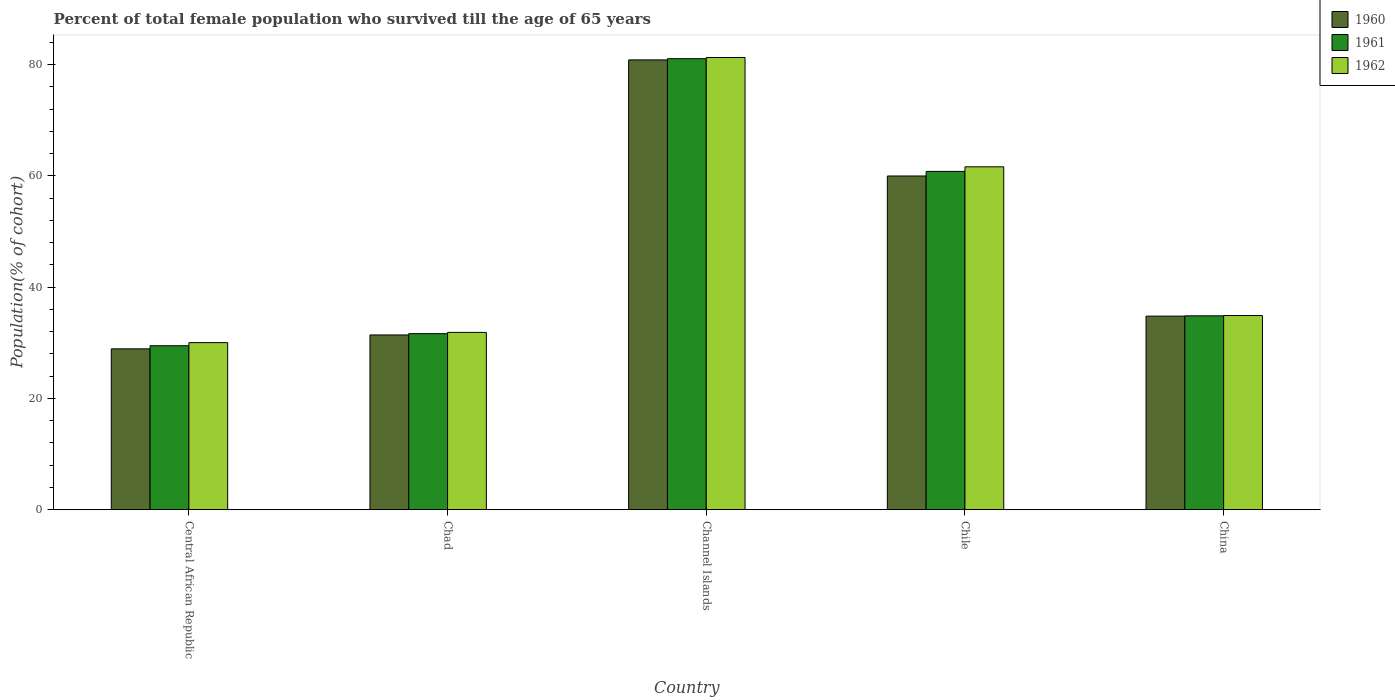Are the number of bars on each tick of the X-axis equal?
Your answer should be compact. Yes. How many bars are there on the 5th tick from the left?
Keep it short and to the point. 3. How many bars are there on the 2nd tick from the right?
Ensure brevity in your answer.  3. What is the label of the 2nd group of bars from the left?
Your answer should be compact. Chad. What is the percentage of total female population who survived till the age of 65 years in 1960 in Central African Republic?
Your response must be concise. 28.91. Across all countries, what is the maximum percentage of total female population who survived till the age of 65 years in 1960?
Offer a terse response. 80.85. Across all countries, what is the minimum percentage of total female population who survived till the age of 65 years in 1962?
Your answer should be compact. 30.03. In which country was the percentage of total female population who survived till the age of 65 years in 1962 maximum?
Offer a very short reply. Channel Islands. In which country was the percentage of total female population who survived till the age of 65 years in 1960 minimum?
Offer a very short reply. Central African Republic. What is the total percentage of total female population who survived till the age of 65 years in 1961 in the graph?
Provide a succinct answer. 237.84. What is the difference between the percentage of total female population who survived till the age of 65 years in 1961 in Chad and that in Channel Islands?
Give a very brief answer. -49.43. What is the difference between the percentage of total female population who survived till the age of 65 years in 1961 in China and the percentage of total female population who survived till the age of 65 years in 1960 in Chile?
Offer a very short reply. -25.13. What is the average percentage of total female population who survived till the age of 65 years in 1962 per country?
Offer a very short reply. 47.94. What is the difference between the percentage of total female population who survived till the age of 65 years of/in 1960 and percentage of total female population who survived till the age of 65 years of/in 1961 in Central African Republic?
Provide a short and direct response. -0.56. What is the ratio of the percentage of total female population who survived till the age of 65 years in 1961 in Chad to that in Chile?
Offer a very short reply. 0.52. Is the difference between the percentage of total female population who survived till the age of 65 years in 1960 in Channel Islands and Chile greater than the difference between the percentage of total female population who survived till the age of 65 years in 1961 in Channel Islands and Chile?
Offer a terse response. Yes. What is the difference between the highest and the second highest percentage of total female population who survived till the age of 65 years in 1960?
Offer a very short reply. 46.06. What is the difference between the highest and the lowest percentage of total female population who survived till the age of 65 years in 1962?
Offer a terse response. 51.26. In how many countries, is the percentage of total female population who survived till the age of 65 years in 1960 greater than the average percentage of total female population who survived till the age of 65 years in 1960 taken over all countries?
Provide a succinct answer. 2. Is the sum of the percentage of total female population who survived till the age of 65 years in 1960 in Chile and China greater than the maximum percentage of total female population who survived till the age of 65 years in 1962 across all countries?
Ensure brevity in your answer.  Yes. Is it the case that in every country, the sum of the percentage of total female population who survived till the age of 65 years in 1961 and percentage of total female population who survived till the age of 65 years in 1962 is greater than the percentage of total female population who survived till the age of 65 years in 1960?
Provide a succinct answer. Yes. Are all the bars in the graph horizontal?
Ensure brevity in your answer.  No. How many countries are there in the graph?
Your answer should be very brief. 5. Are the values on the major ticks of Y-axis written in scientific E-notation?
Your response must be concise. No. Does the graph contain any zero values?
Provide a succinct answer. No. What is the title of the graph?
Your answer should be compact. Percent of total female population who survived till the age of 65 years. Does "1969" appear as one of the legend labels in the graph?
Your answer should be very brief. No. What is the label or title of the Y-axis?
Provide a short and direct response. Population(% of cohort). What is the Population(% of cohort) of 1960 in Central African Republic?
Your answer should be very brief. 28.91. What is the Population(% of cohort) in 1961 in Central African Republic?
Ensure brevity in your answer.  29.47. What is the Population(% of cohort) of 1962 in Central African Republic?
Give a very brief answer. 30.03. What is the Population(% of cohort) of 1960 in Chad?
Ensure brevity in your answer.  31.41. What is the Population(% of cohort) of 1961 in Chad?
Your answer should be compact. 31.64. What is the Population(% of cohort) of 1962 in Chad?
Provide a short and direct response. 31.87. What is the Population(% of cohort) in 1960 in Channel Islands?
Your answer should be very brief. 80.85. What is the Population(% of cohort) of 1961 in Channel Islands?
Offer a very short reply. 81.07. What is the Population(% of cohort) of 1962 in Channel Islands?
Provide a short and direct response. 81.28. What is the Population(% of cohort) of 1960 in Chile?
Ensure brevity in your answer.  59.98. What is the Population(% of cohort) in 1961 in Chile?
Provide a succinct answer. 60.81. What is the Population(% of cohort) of 1962 in Chile?
Your answer should be very brief. 61.63. What is the Population(% of cohort) of 1960 in China?
Offer a very short reply. 34.79. What is the Population(% of cohort) of 1961 in China?
Your answer should be compact. 34.85. What is the Population(% of cohort) in 1962 in China?
Provide a succinct answer. 34.9. Across all countries, what is the maximum Population(% of cohort) in 1960?
Make the answer very short. 80.85. Across all countries, what is the maximum Population(% of cohort) of 1961?
Keep it short and to the point. 81.07. Across all countries, what is the maximum Population(% of cohort) in 1962?
Offer a very short reply. 81.28. Across all countries, what is the minimum Population(% of cohort) of 1960?
Ensure brevity in your answer.  28.91. Across all countries, what is the minimum Population(% of cohort) of 1961?
Provide a short and direct response. 29.47. Across all countries, what is the minimum Population(% of cohort) in 1962?
Offer a very short reply. 30.03. What is the total Population(% of cohort) of 1960 in the graph?
Keep it short and to the point. 235.95. What is the total Population(% of cohort) of 1961 in the graph?
Ensure brevity in your answer.  237.84. What is the total Population(% of cohort) in 1962 in the graph?
Keep it short and to the point. 239.72. What is the difference between the Population(% of cohort) of 1960 in Central African Republic and that in Chad?
Ensure brevity in your answer.  -2.5. What is the difference between the Population(% of cohort) in 1961 in Central African Republic and that in Chad?
Ensure brevity in your answer.  -2.17. What is the difference between the Population(% of cohort) of 1962 in Central African Republic and that in Chad?
Your response must be concise. -1.84. What is the difference between the Population(% of cohort) in 1960 in Central African Republic and that in Channel Islands?
Your answer should be compact. -51.94. What is the difference between the Population(% of cohort) in 1961 in Central African Republic and that in Channel Islands?
Your answer should be very brief. -51.6. What is the difference between the Population(% of cohort) in 1962 in Central African Republic and that in Channel Islands?
Your answer should be very brief. -51.26. What is the difference between the Population(% of cohort) of 1960 in Central African Republic and that in Chile?
Keep it short and to the point. -31.07. What is the difference between the Population(% of cohort) of 1961 in Central African Republic and that in Chile?
Offer a terse response. -31.34. What is the difference between the Population(% of cohort) of 1962 in Central African Republic and that in Chile?
Your answer should be compact. -31.6. What is the difference between the Population(% of cohort) in 1960 in Central African Republic and that in China?
Keep it short and to the point. -5.88. What is the difference between the Population(% of cohort) in 1961 in Central African Republic and that in China?
Provide a succinct answer. -5.38. What is the difference between the Population(% of cohort) in 1962 in Central African Republic and that in China?
Your answer should be compact. -4.88. What is the difference between the Population(% of cohort) in 1960 in Chad and that in Channel Islands?
Keep it short and to the point. -49.44. What is the difference between the Population(% of cohort) in 1961 in Chad and that in Channel Islands?
Your answer should be very brief. -49.43. What is the difference between the Population(% of cohort) of 1962 in Chad and that in Channel Islands?
Provide a succinct answer. -49.41. What is the difference between the Population(% of cohort) of 1960 in Chad and that in Chile?
Your response must be concise. -28.57. What is the difference between the Population(% of cohort) in 1961 in Chad and that in Chile?
Provide a succinct answer. -29.16. What is the difference between the Population(% of cohort) of 1962 in Chad and that in Chile?
Offer a very short reply. -29.76. What is the difference between the Population(% of cohort) of 1960 in Chad and that in China?
Ensure brevity in your answer.  -3.38. What is the difference between the Population(% of cohort) of 1961 in Chad and that in China?
Offer a very short reply. -3.21. What is the difference between the Population(% of cohort) of 1962 in Chad and that in China?
Ensure brevity in your answer.  -3.03. What is the difference between the Population(% of cohort) in 1960 in Channel Islands and that in Chile?
Offer a terse response. 20.87. What is the difference between the Population(% of cohort) in 1961 in Channel Islands and that in Chile?
Your answer should be very brief. 20.26. What is the difference between the Population(% of cohort) of 1962 in Channel Islands and that in Chile?
Ensure brevity in your answer.  19.65. What is the difference between the Population(% of cohort) of 1960 in Channel Islands and that in China?
Your response must be concise. 46.06. What is the difference between the Population(% of cohort) of 1961 in Channel Islands and that in China?
Keep it short and to the point. 46.22. What is the difference between the Population(% of cohort) of 1962 in Channel Islands and that in China?
Ensure brevity in your answer.  46.38. What is the difference between the Population(% of cohort) of 1960 in Chile and that in China?
Offer a terse response. 25.19. What is the difference between the Population(% of cohort) of 1961 in Chile and that in China?
Your answer should be very brief. 25.96. What is the difference between the Population(% of cohort) in 1962 in Chile and that in China?
Offer a very short reply. 26.73. What is the difference between the Population(% of cohort) of 1960 in Central African Republic and the Population(% of cohort) of 1961 in Chad?
Provide a short and direct response. -2.73. What is the difference between the Population(% of cohort) in 1960 in Central African Republic and the Population(% of cohort) in 1962 in Chad?
Your answer should be compact. -2.96. What is the difference between the Population(% of cohort) of 1961 in Central African Republic and the Population(% of cohort) of 1962 in Chad?
Ensure brevity in your answer.  -2.4. What is the difference between the Population(% of cohort) of 1960 in Central African Republic and the Population(% of cohort) of 1961 in Channel Islands?
Your response must be concise. -52.16. What is the difference between the Population(% of cohort) of 1960 in Central African Republic and the Population(% of cohort) of 1962 in Channel Islands?
Your answer should be very brief. -52.37. What is the difference between the Population(% of cohort) of 1961 in Central African Republic and the Population(% of cohort) of 1962 in Channel Islands?
Offer a terse response. -51.81. What is the difference between the Population(% of cohort) of 1960 in Central African Republic and the Population(% of cohort) of 1961 in Chile?
Your answer should be compact. -31.89. What is the difference between the Population(% of cohort) of 1960 in Central African Republic and the Population(% of cohort) of 1962 in Chile?
Keep it short and to the point. -32.72. What is the difference between the Population(% of cohort) in 1961 in Central African Republic and the Population(% of cohort) in 1962 in Chile?
Offer a very short reply. -32.16. What is the difference between the Population(% of cohort) in 1960 in Central African Republic and the Population(% of cohort) in 1961 in China?
Offer a very short reply. -5.94. What is the difference between the Population(% of cohort) in 1960 in Central African Republic and the Population(% of cohort) in 1962 in China?
Offer a terse response. -5.99. What is the difference between the Population(% of cohort) in 1961 in Central African Republic and the Population(% of cohort) in 1962 in China?
Ensure brevity in your answer.  -5.43. What is the difference between the Population(% of cohort) in 1960 in Chad and the Population(% of cohort) in 1961 in Channel Islands?
Offer a very short reply. -49.66. What is the difference between the Population(% of cohort) of 1960 in Chad and the Population(% of cohort) of 1962 in Channel Islands?
Provide a short and direct response. -49.87. What is the difference between the Population(% of cohort) in 1961 in Chad and the Population(% of cohort) in 1962 in Channel Islands?
Your answer should be very brief. -49.64. What is the difference between the Population(% of cohort) in 1960 in Chad and the Population(% of cohort) in 1961 in Chile?
Your answer should be compact. -29.39. What is the difference between the Population(% of cohort) of 1960 in Chad and the Population(% of cohort) of 1962 in Chile?
Provide a short and direct response. -30.22. What is the difference between the Population(% of cohort) of 1961 in Chad and the Population(% of cohort) of 1962 in Chile?
Give a very brief answer. -29.99. What is the difference between the Population(% of cohort) in 1960 in Chad and the Population(% of cohort) in 1961 in China?
Your answer should be very brief. -3.44. What is the difference between the Population(% of cohort) of 1960 in Chad and the Population(% of cohort) of 1962 in China?
Provide a succinct answer. -3.49. What is the difference between the Population(% of cohort) in 1961 in Chad and the Population(% of cohort) in 1962 in China?
Provide a short and direct response. -3.26. What is the difference between the Population(% of cohort) of 1960 in Channel Islands and the Population(% of cohort) of 1961 in Chile?
Your answer should be compact. 20.04. What is the difference between the Population(% of cohort) in 1960 in Channel Islands and the Population(% of cohort) in 1962 in Chile?
Provide a succinct answer. 19.22. What is the difference between the Population(% of cohort) of 1961 in Channel Islands and the Population(% of cohort) of 1962 in Chile?
Offer a very short reply. 19.44. What is the difference between the Population(% of cohort) of 1960 in Channel Islands and the Population(% of cohort) of 1961 in China?
Offer a very short reply. 46. What is the difference between the Population(% of cohort) of 1960 in Channel Islands and the Population(% of cohort) of 1962 in China?
Offer a terse response. 45.95. What is the difference between the Population(% of cohort) of 1961 in Channel Islands and the Population(% of cohort) of 1962 in China?
Give a very brief answer. 46.16. What is the difference between the Population(% of cohort) of 1960 in Chile and the Population(% of cohort) of 1961 in China?
Offer a terse response. 25.13. What is the difference between the Population(% of cohort) of 1960 in Chile and the Population(% of cohort) of 1962 in China?
Provide a short and direct response. 25.08. What is the difference between the Population(% of cohort) of 1961 in Chile and the Population(% of cohort) of 1962 in China?
Your answer should be compact. 25.9. What is the average Population(% of cohort) in 1960 per country?
Ensure brevity in your answer.  47.19. What is the average Population(% of cohort) in 1961 per country?
Your answer should be compact. 47.57. What is the average Population(% of cohort) in 1962 per country?
Offer a terse response. 47.94. What is the difference between the Population(% of cohort) in 1960 and Population(% of cohort) in 1961 in Central African Republic?
Offer a terse response. -0.56. What is the difference between the Population(% of cohort) in 1960 and Population(% of cohort) in 1962 in Central African Republic?
Give a very brief answer. -1.12. What is the difference between the Population(% of cohort) in 1961 and Population(% of cohort) in 1962 in Central African Republic?
Offer a very short reply. -0.56. What is the difference between the Population(% of cohort) in 1960 and Population(% of cohort) in 1961 in Chad?
Offer a terse response. -0.23. What is the difference between the Population(% of cohort) of 1960 and Population(% of cohort) of 1962 in Chad?
Your answer should be compact. -0.46. What is the difference between the Population(% of cohort) of 1961 and Population(% of cohort) of 1962 in Chad?
Keep it short and to the point. -0.23. What is the difference between the Population(% of cohort) of 1960 and Population(% of cohort) of 1961 in Channel Islands?
Make the answer very short. -0.22. What is the difference between the Population(% of cohort) in 1960 and Population(% of cohort) in 1962 in Channel Islands?
Give a very brief answer. -0.43. What is the difference between the Population(% of cohort) of 1961 and Population(% of cohort) of 1962 in Channel Islands?
Ensure brevity in your answer.  -0.22. What is the difference between the Population(% of cohort) in 1960 and Population(% of cohort) in 1961 in Chile?
Your response must be concise. -0.82. What is the difference between the Population(% of cohort) in 1960 and Population(% of cohort) in 1962 in Chile?
Make the answer very short. -1.65. What is the difference between the Population(% of cohort) in 1961 and Population(% of cohort) in 1962 in Chile?
Provide a short and direct response. -0.82. What is the difference between the Population(% of cohort) in 1960 and Population(% of cohort) in 1961 in China?
Ensure brevity in your answer.  -0.06. What is the difference between the Population(% of cohort) of 1960 and Population(% of cohort) of 1962 in China?
Offer a terse response. -0.11. What is the difference between the Population(% of cohort) in 1961 and Population(% of cohort) in 1962 in China?
Offer a terse response. -0.06. What is the ratio of the Population(% of cohort) of 1960 in Central African Republic to that in Chad?
Your answer should be very brief. 0.92. What is the ratio of the Population(% of cohort) in 1961 in Central African Republic to that in Chad?
Provide a succinct answer. 0.93. What is the ratio of the Population(% of cohort) in 1962 in Central African Republic to that in Chad?
Your response must be concise. 0.94. What is the ratio of the Population(% of cohort) in 1960 in Central African Republic to that in Channel Islands?
Offer a terse response. 0.36. What is the ratio of the Population(% of cohort) in 1961 in Central African Republic to that in Channel Islands?
Make the answer very short. 0.36. What is the ratio of the Population(% of cohort) in 1962 in Central African Republic to that in Channel Islands?
Make the answer very short. 0.37. What is the ratio of the Population(% of cohort) in 1960 in Central African Republic to that in Chile?
Ensure brevity in your answer.  0.48. What is the ratio of the Population(% of cohort) of 1961 in Central African Republic to that in Chile?
Make the answer very short. 0.48. What is the ratio of the Population(% of cohort) in 1962 in Central African Republic to that in Chile?
Provide a succinct answer. 0.49. What is the ratio of the Population(% of cohort) of 1960 in Central African Republic to that in China?
Ensure brevity in your answer.  0.83. What is the ratio of the Population(% of cohort) of 1961 in Central African Republic to that in China?
Your answer should be very brief. 0.85. What is the ratio of the Population(% of cohort) of 1962 in Central African Republic to that in China?
Give a very brief answer. 0.86. What is the ratio of the Population(% of cohort) in 1960 in Chad to that in Channel Islands?
Your answer should be compact. 0.39. What is the ratio of the Population(% of cohort) of 1961 in Chad to that in Channel Islands?
Your response must be concise. 0.39. What is the ratio of the Population(% of cohort) of 1962 in Chad to that in Channel Islands?
Offer a very short reply. 0.39. What is the ratio of the Population(% of cohort) of 1960 in Chad to that in Chile?
Offer a terse response. 0.52. What is the ratio of the Population(% of cohort) of 1961 in Chad to that in Chile?
Provide a succinct answer. 0.52. What is the ratio of the Population(% of cohort) in 1962 in Chad to that in Chile?
Make the answer very short. 0.52. What is the ratio of the Population(% of cohort) in 1960 in Chad to that in China?
Give a very brief answer. 0.9. What is the ratio of the Population(% of cohort) of 1961 in Chad to that in China?
Your answer should be compact. 0.91. What is the ratio of the Population(% of cohort) in 1962 in Chad to that in China?
Give a very brief answer. 0.91. What is the ratio of the Population(% of cohort) of 1960 in Channel Islands to that in Chile?
Provide a succinct answer. 1.35. What is the ratio of the Population(% of cohort) of 1961 in Channel Islands to that in Chile?
Your answer should be compact. 1.33. What is the ratio of the Population(% of cohort) of 1962 in Channel Islands to that in Chile?
Provide a short and direct response. 1.32. What is the ratio of the Population(% of cohort) in 1960 in Channel Islands to that in China?
Make the answer very short. 2.32. What is the ratio of the Population(% of cohort) in 1961 in Channel Islands to that in China?
Give a very brief answer. 2.33. What is the ratio of the Population(% of cohort) in 1962 in Channel Islands to that in China?
Make the answer very short. 2.33. What is the ratio of the Population(% of cohort) of 1960 in Chile to that in China?
Your response must be concise. 1.72. What is the ratio of the Population(% of cohort) in 1961 in Chile to that in China?
Your answer should be very brief. 1.74. What is the ratio of the Population(% of cohort) in 1962 in Chile to that in China?
Your answer should be compact. 1.77. What is the difference between the highest and the second highest Population(% of cohort) of 1960?
Make the answer very short. 20.87. What is the difference between the highest and the second highest Population(% of cohort) in 1961?
Your answer should be compact. 20.26. What is the difference between the highest and the second highest Population(% of cohort) in 1962?
Give a very brief answer. 19.65. What is the difference between the highest and the lowest Population(% of cohort) of 1960?
Your response must be concise. 51.94. What is the difference between the highest and the lowest Population(% of cohort) of 1961?
Keep it short and to the point. 51.6. What is the difference between the highest and the lowest Population(% of cohort) of 1962?
Offer a very short reply. 51.26. 